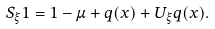Convert formula to latex. <formula><loc_0><loc_0><loc_500><loc_500>S _ { \xi } 1 = 1 - \mu + q ( x ) + U _ { \xi } q ( x ) .</formula> 